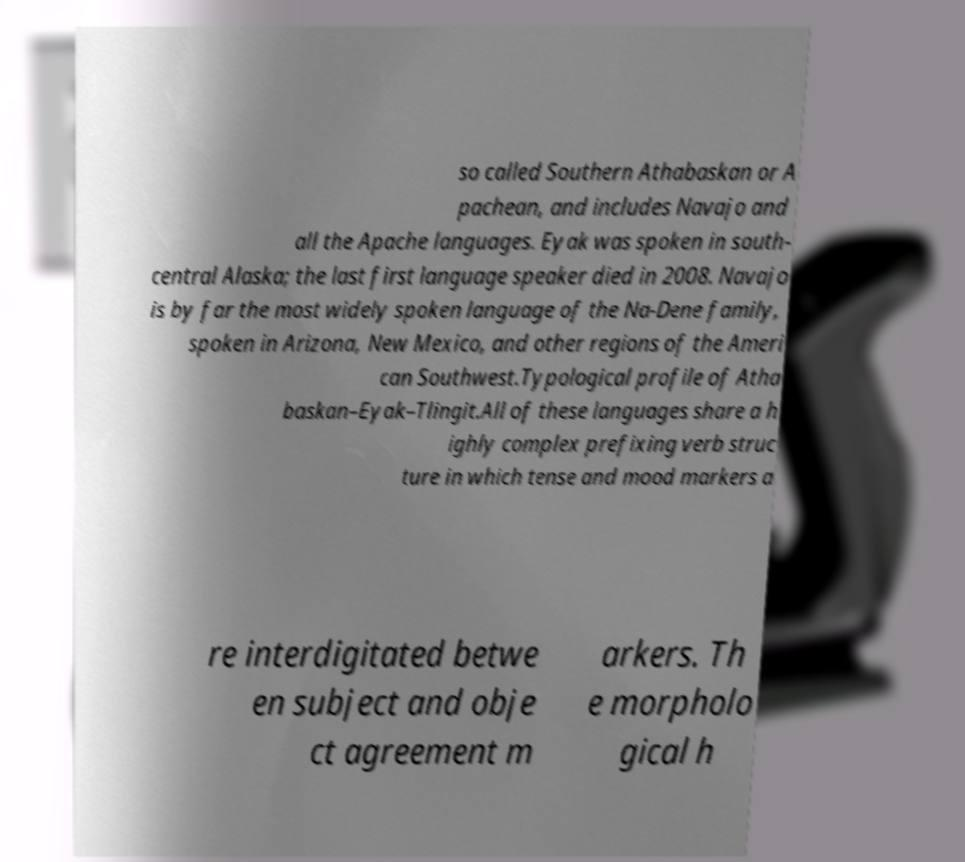There's text embedded in this image that I need extracted. Can you transcribe it verbatim? so called Southern Athabaskan or A pachean, and includes Navajo and all the Apache languages. Eyak was spoken in south- central Alaska; the last first language speaker died in 2008. Navajo is by far the most widely spoken language of the Na-Dene family, spoken in Arizona, New Mexico, and other regions of the Ameri can Southwest.Typological profile of Atha baskan–Eyak–Tlingit.All of these languages share a h ighly complex prefixing verb struc ture in which tense and mood markers a re interdigitated betwe en subject and obje ct agreement m arkers. Th e morpholo gical h 